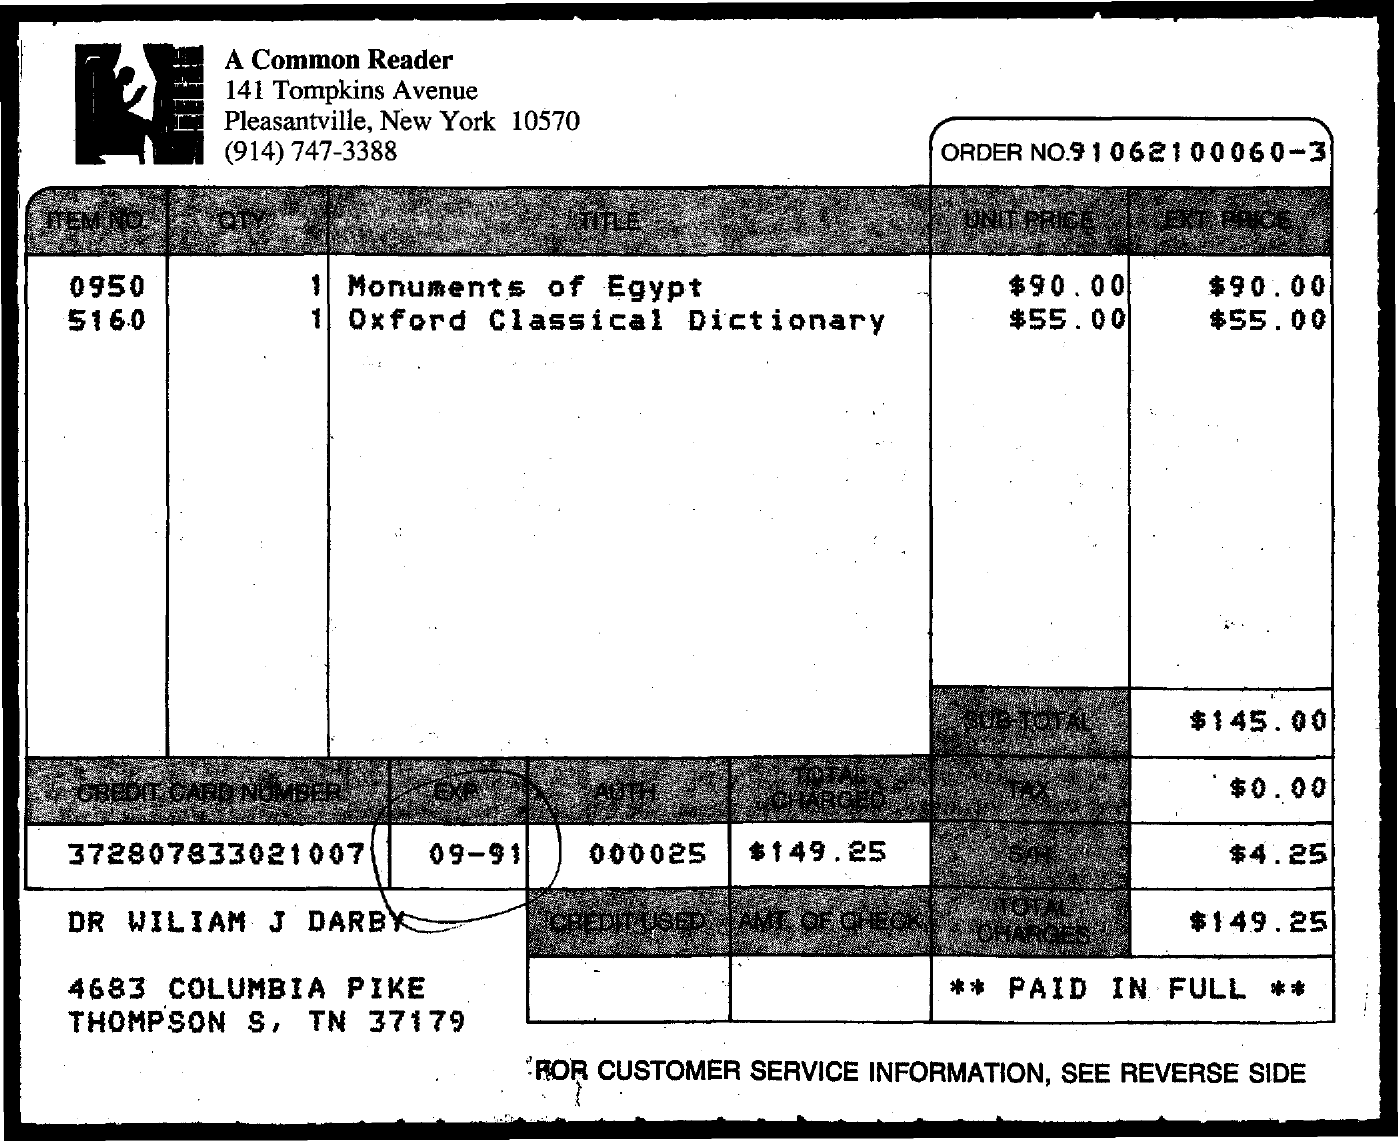Highlight a few significant elements in this photo. The total charges amount to $149.25. The credit card number mentioned is 372807833021007. What is mentioned is 09-91. 